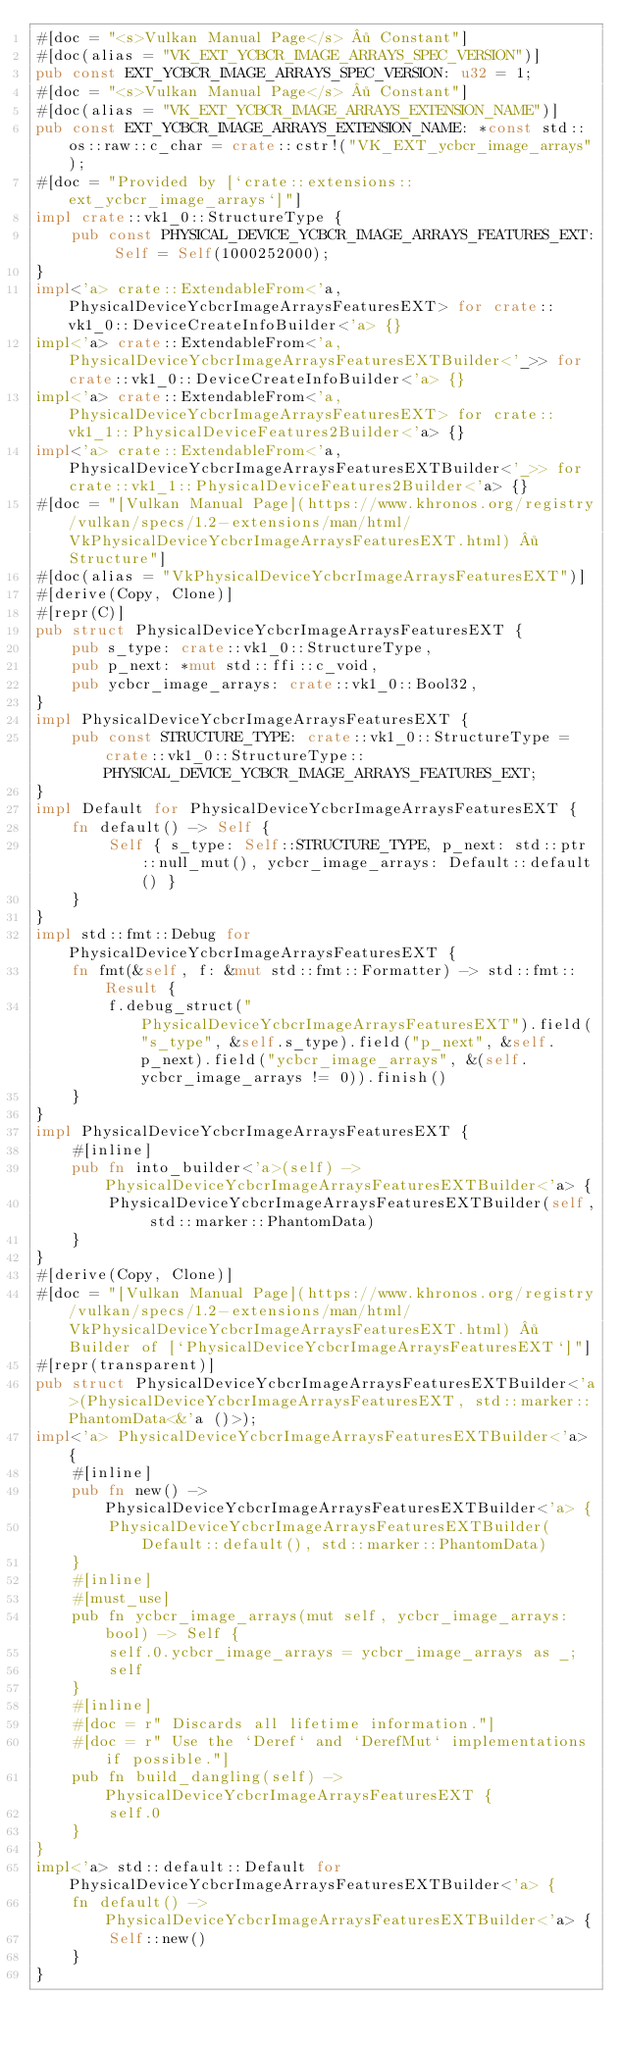Convert code to text. <code><loc_0><loc_0><loc_500><loc_500><_Rust_>#[doc = "<s>Vulkan Manual Page</s> · Constant"]
#[doc(alias = "VK_EXT_YCBCR_IMAGE_ARRAYS_SPEC_VERSION")]
pub const EXT_YCBCR_IMAGE_ARRAYS_SPEC_VERSION: u32 = 1;
#[doc = "<s>Vulkan Manual Page</s> · Constant"]
#[doc(alias = "VK_EXT_YCBCR_IMAGE_ARRAYS_EXTENSION_NAME")]
pub const EXT_YCBCR_IMAGE_ARRAYS_EXTENSION_NAME: *const std::os::raw::c_char = crate::cstr!("VK_EXT_ycbcr_image_arrays");
#[doc = "Provided by [`crate::extensions::ext_ycbcr_image_arrays`]"]
impl crate::vk1_0::StructureType {
    pub const PHYSICAL_DEVICE_YCBCR_IMAGE_ARRAYS_FEATURES_EXT: Self = Self(1000252000);
}
impl<'a> crate::ExtendableFrom<'a, PhysicalDeviceYcbcrImageArraysFeaturesEXT> for crate::vk1_0::DeviceCreateInfoBuilder<'a> {}
impl<'a> crate::ExtendableFrom<'a, PhysicalDeviceYcbcrImageArraysFeaturesEXTBuilder<'_>> for crate::vk1_0::DeviceCreateInfoBuilder<'a> {}
impl<'a> crate::ExtendableFrom<'a, PhysicalDeviceYcbcrImageArraysFeaturesEXT> for crate::vk1_1::PhysicalDeviceFeatures2Builder<'a> {}
impl<'a> crate::ExtendableFrom<'a, PhysicalDeviceYcbcrImageArraysFeaturesEXTBuilder<'_>> for crate::vk1_1::PhysicalDeviceFeatures2Builder<'a> {}
#[doc = "[Vulkan Manual Page](https://www.khronos.org/registry/vulkan/specs/1.2-extensions/man/html/VkPhysicalDeviceYcbcrImageArraysFeaturesEXT.html) · Structure"]
#[doc(alias = "VkPhysicalDeviceYcbcrImageArraysFeaturesEXT")]
#[derive(Copy, Clone)]
#[repr(C)]
pub struct PhysicalDeviceYcbcrImageArraysFeaturesEXT {
    pub s_type: crate::vk1_0::StructureType,
    pub p_next: *mut std::ffi::c_void,
    pub ycbcr_image_arrays: crate::vk1_0::Bool32,
}
impl PhysicalDeviceYcbcrImageArraysFeaturesEXT {
    pub const STRUCTURE_TYPE: crate::vk1_0::StructureType = crate::vk1_0::StructureType::PHYSICAL_DEVICE_YCBCR_IMAGE_ARRAYS_FEATURES_EXT;
}
impl Default for PhysicalDeviceYcbcrImageArraysFeaturesEXT {
    fn default() -> Self {
        Self { s_type: Self::STRUCTURE_TYPE, p_next: std::ptr::null_mut(), ycbcr_image_arrays: Default::default() }
    }
}
impl std::fmt::Debug for PhysicalDeviceYcbcrImageArraysFeaturesEXT {
    fn fmt(&self, f: &mut std::fmt::Formatter) -> std::fmt::Result {
        f.debug_struct("PhysicalDeviceYcbcrImageArraysFeaturesEXT").field("s_type", &self.s_type).field("p_next", &self.p_next).field("ycbcr_image_arrays", &(self.ycbcr_image_arrays != 0)).finish()
    }
}
impl PhysicalDeviceYcbcrImageArraysFeaturesEXT {
    #[inline]
    pub fn into_builder<'a>(self) -> PhysicalDeviceYcbcrImageArraysFeaturesEXTBuilder<'a> {
        PhysicalDeviceYcbcrImageArraysFeaturesEXTBuilder(self, std::marker::PhantomData)
    }
}
#[derive(Copy, Clone)]
#[doc = "[Vulkan Manual Page](https://www.khronos.org/registry/vulkan/specs/1.2-extensions/man/html/VkPhysicalDeviceYcbcrImageArraysFeaturesEXT.html) · Builder of [`PhysicalDeviceYcbcrImageArraysFeaturesEXT`]"]
#[repr(transparent)]
pub struct PhysicalDeviceYcbcrImageArraysFeaturesEXTBuilder<'a>(PhysicalDeviceYcbcrImageArraysFeaturesEXT, std::marker::PhantomData<&'a ()>);
impl<'a> PhysicalDeviceYcbcrImageArraysFeaturesEXTBuilder<'a> {
    #[inline]
    pub fn new() -> PhysicalDeviceYcbcrImageArraysFeaturesEXTBuilder<'a> {
        PhysicalDeviceYcbcrImageArraysFeaturesEXTBuilder(Default::default(), std::marker::PhantomData)
    }
    #[inline]
    #[must_use]
    pub fn ycbcr_image_arrays(mut self, ycbcr_image_arrays: bool) -> Self {
        self.0.ycbcr_image_arrays = ycbcr_image_arrays as _;
        self
    }
    #[inline]
    #[doc = r" Discards all lifetime information."]
    #[doc = r" Use the `Deref` and `DerefMut` implementations if possible."]
    pub fn build_dangling(self) -> PhysicalDeviceYcbcrImageArraysFeaturesEXT {
        self.0
    }
}
impl<'a> std::default::Default for PhysicalDeviceYcbcrImageArraysFeaturesEXTBuilder<'a> {
    fn default() -> PhysicalDeviceYcbcrImageArraysFeaturesEXTBuilder<'a> {
        Self::new()
    }
}</code> 